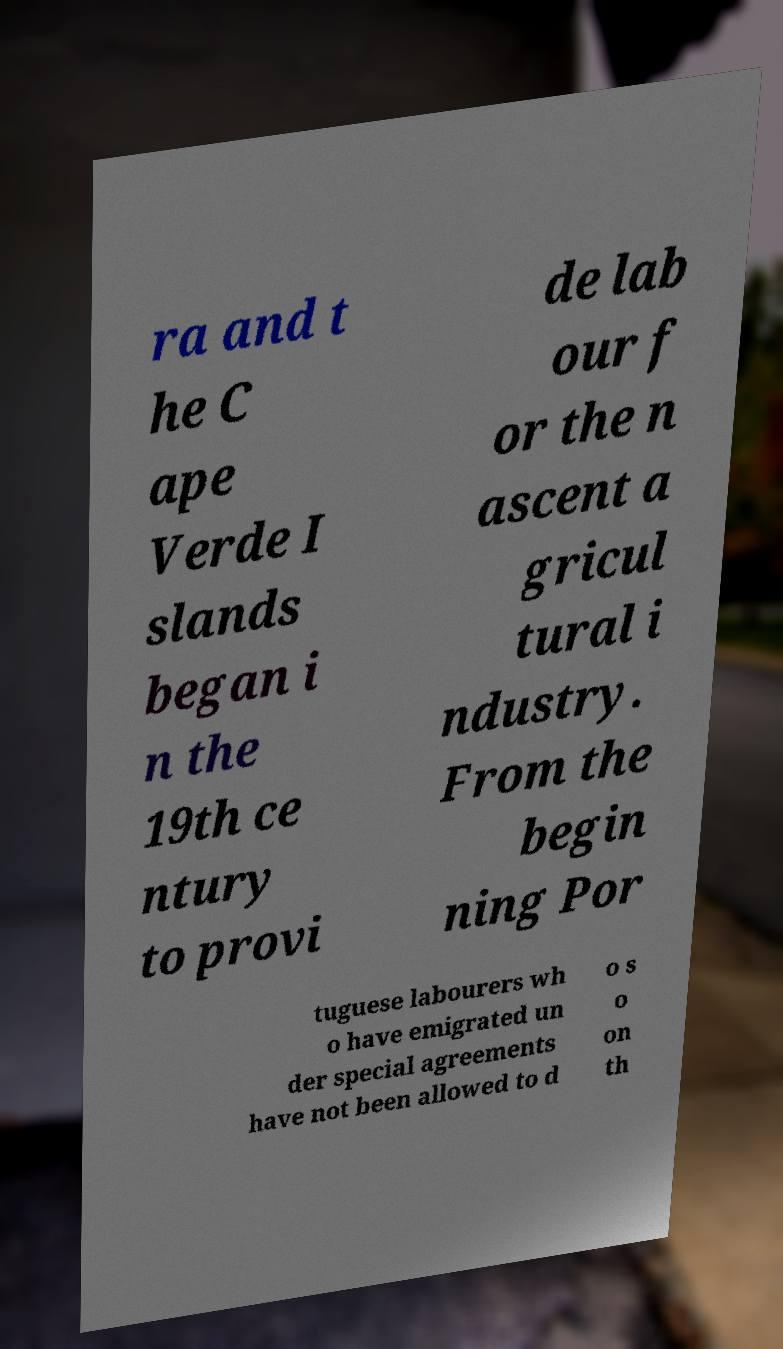Can you read and provide the text displayed in the image?This photo seems to have some interesting text. Can you extract and type it out for me? ra and t he C ape Verde I slands began i n the 19th ce ntury to provi de lab our f or the n ascent a gricul tural i ndustry. From the begin ning Por tuguese labourers wh o have emigrated un der special agreements have not been allowed to d o s o on th 